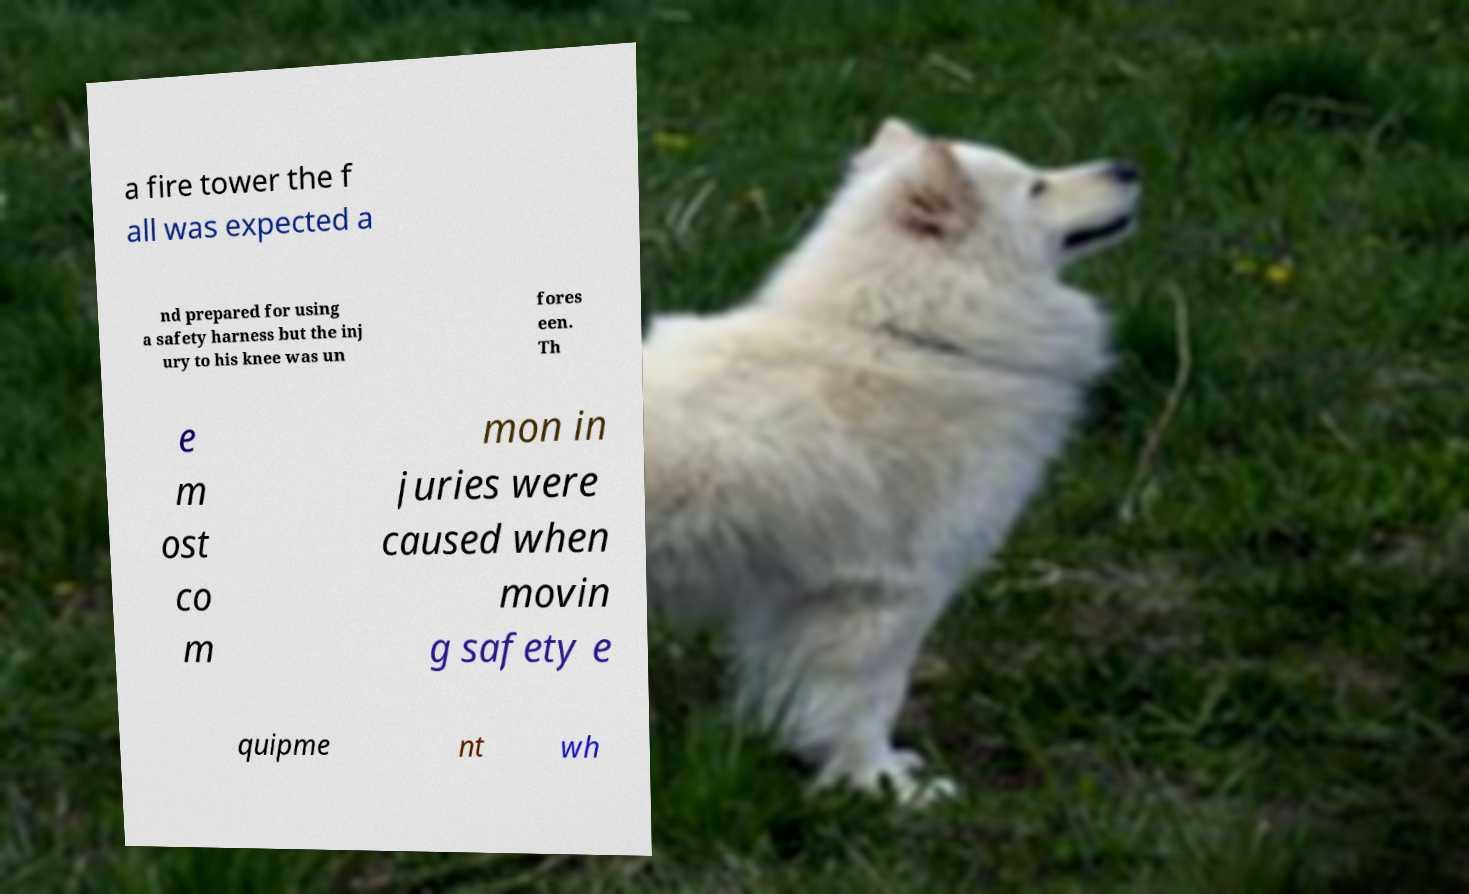Please identify and transcribe the text found in this image. a fire tower the f all was expected a nd prepared for using a safety harness but the inj ury to his knee was un fores een. Th e m ost co m mon in juries were caused when movin g safety e quipme nt wh 